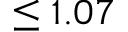Convert formula to latex. <formula><loc_0><loc_0><loc_500><loc_500>\leq 1 . 0 7</formula> 